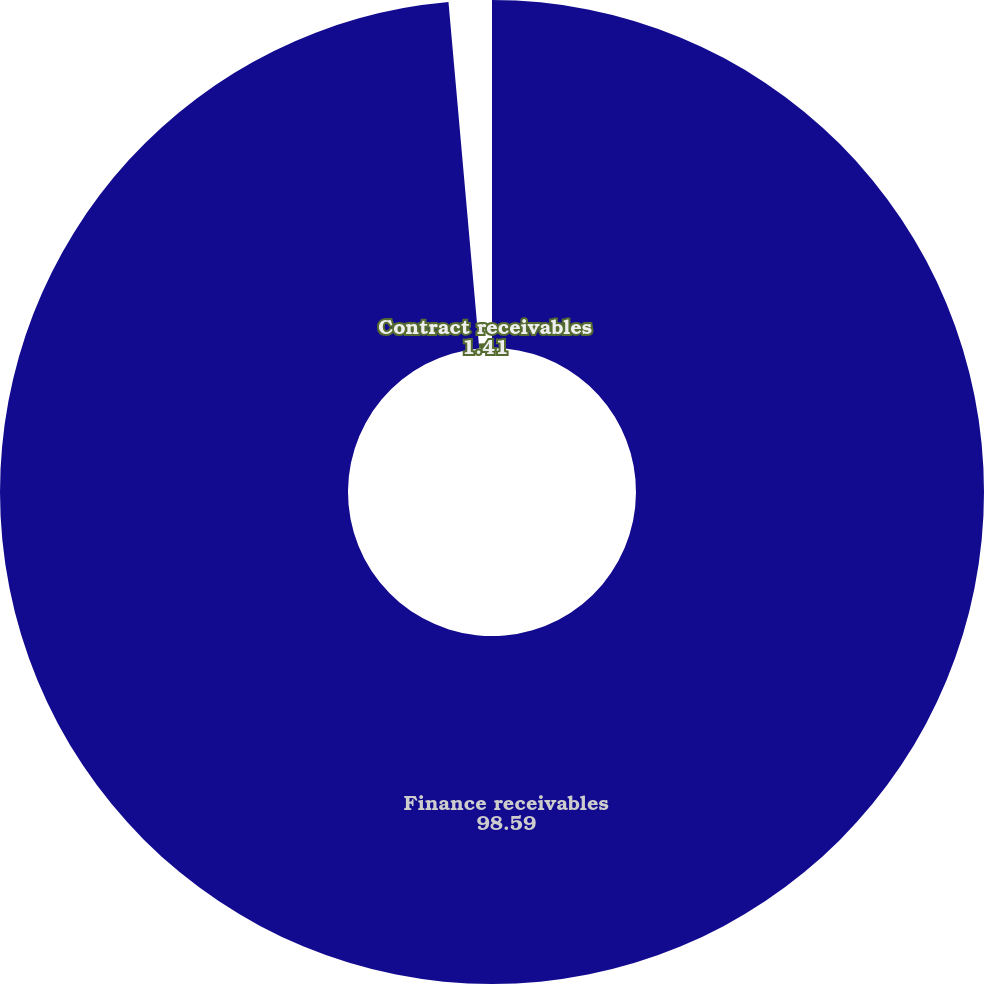Convert chart. <chart><loc_0><loc_0><loc_500><loc_500><pie_chart><fcel>Finance receivables<fcel>Contract receivables<nl><fcel>98.59%<fcel>1.41%<nl></chart> 